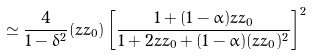Convert formula to latex. <formula><loc_0><loc_0><loc_500><loc_500>\simeq \frac { 4 } { 1 - \delta ^ { 2 } } ( z z _ { 0 } ) \left [ \frac { 1 + ( 1 - \alpha ) z z _ { 0 } } { 1 + 2 z z _ { 0 } + ( 1 - \alpha ) ( z z _ { 0 } ) ^ { 2 } } \right ] ^ { 2 }</formula> 